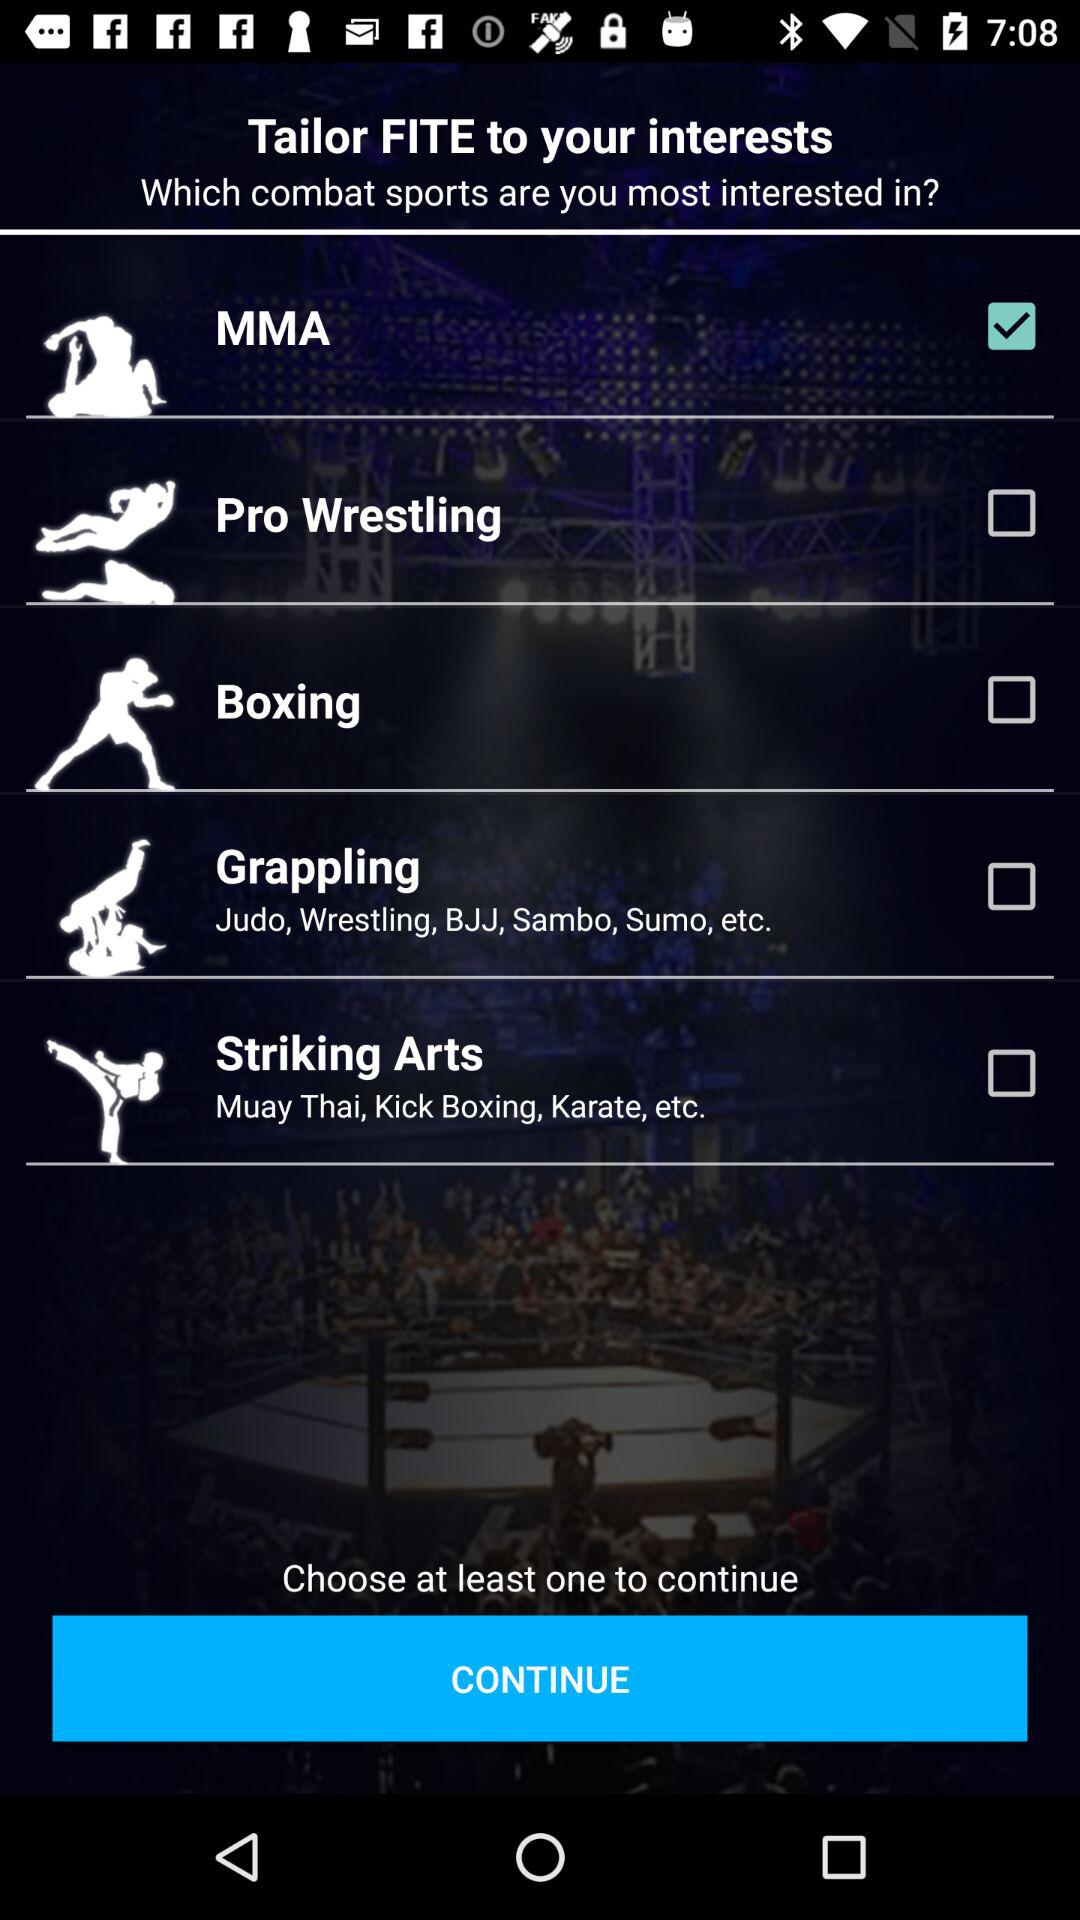How many combat sports can I select?
Answer the question using a single word or phrase. 5 